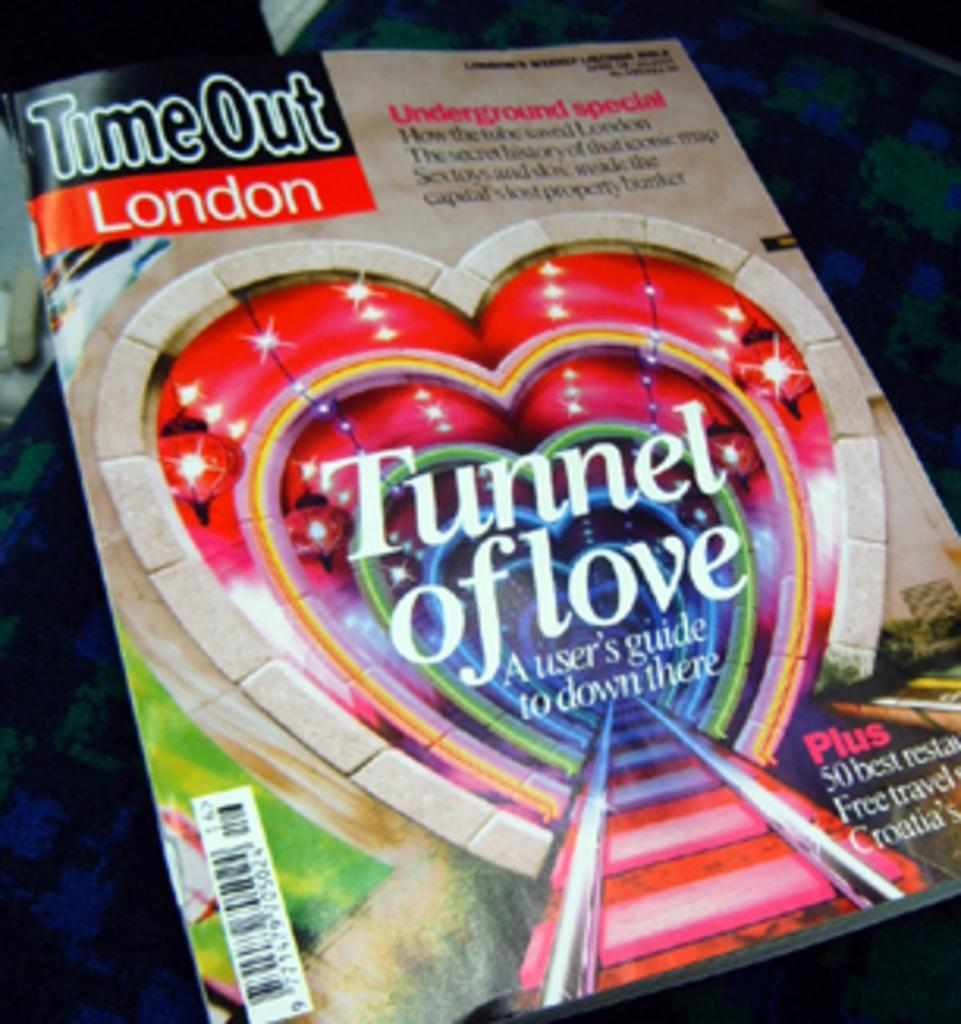<image>
Share a concise interpretation of the image provided. Timeout London magazine with the tunnel of love 